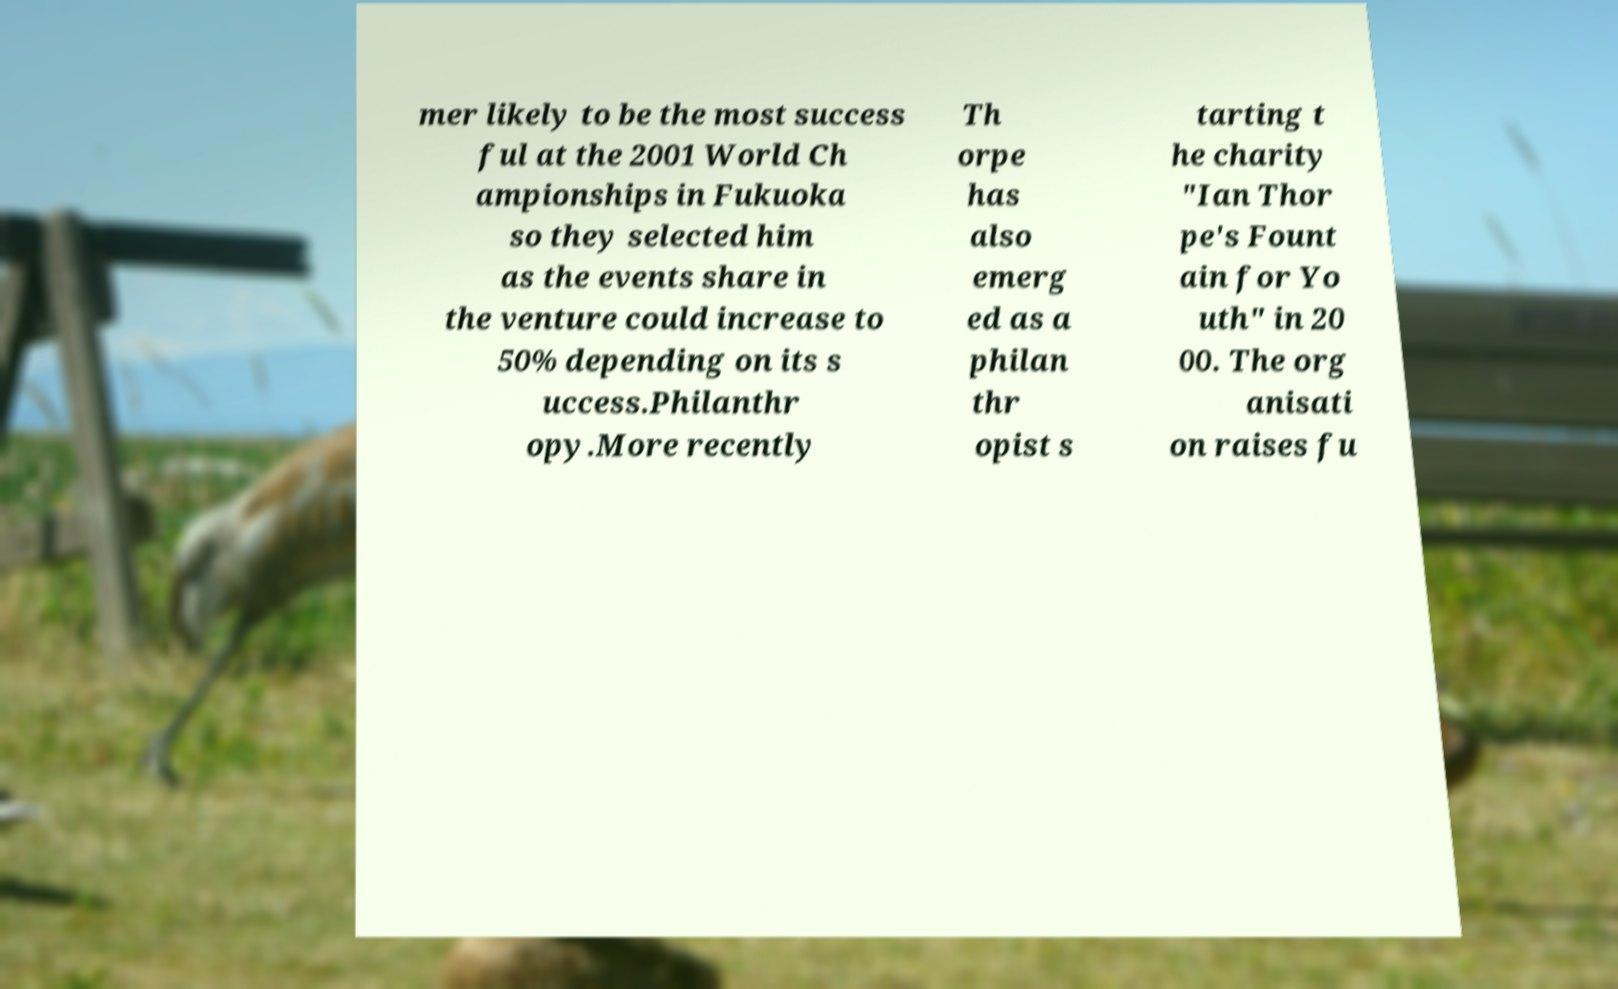I need the written content from this picture converted into text. Can you do that? mer likely to be the most success ful at the 2001 World Ch ampionships in Fukuoka so they selected him as the events share in the venture could increase to 50% depending on its s uccess.Philanthr opy.More recently Th orpe has also emerg ed as a philan thr opist s tarting t he charity "Ian Thor pe's Fount ain for Yo uth" in 20 00. The org anisati on raises fu 